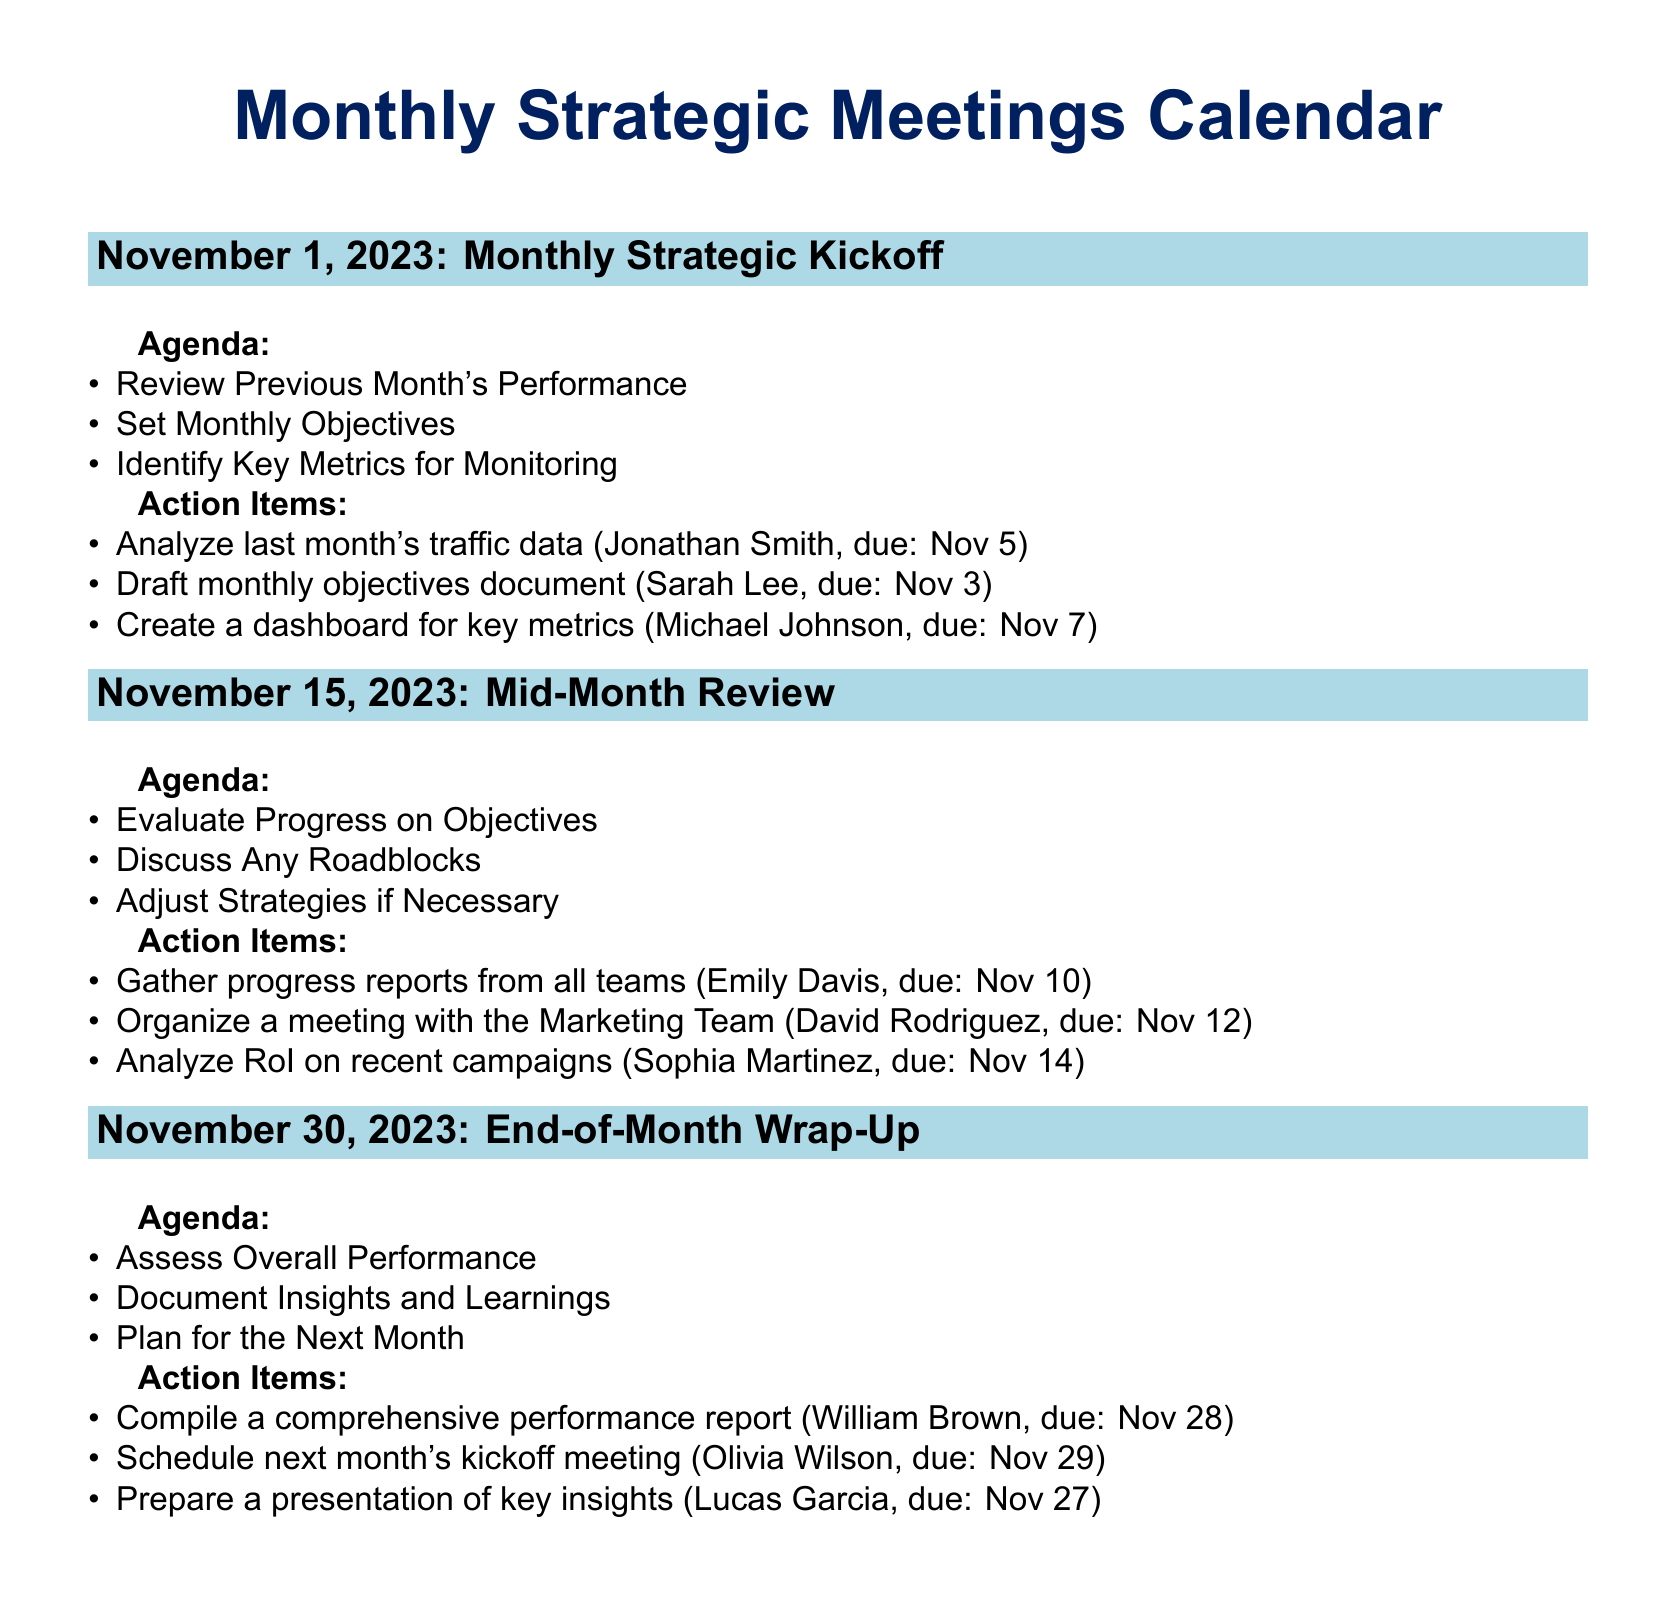What is the date of the Monthly Strategic Kickoff meeting? The date of the Monthly Strategic Kickoff meeting is listed in the document.
Answer: November 1, 2023 Who is responsible for drafting the monthly objectives document? The document specifies action items with assigned responsibilities.
Answer: Sarah Lee What is one of the items discussed during the Mid-Month Review? The document lists agenda items for each meeting.
Answer: Evaluate Progress on Objectives What action item is due on November 14? The document includes a list of action items with their due dates.
Answer: Analyze RoI on recent campaigns How many meetings are scheduled for November 2023? The document outlines three meetings for the month.
Answer: Three What is the purpose of the End-of-Month Wrap-Up meeting? The agenda describes the purpose of each meeting.
Answer: Assess Overall Performance Who is to compile the comprehensive performance report? The document lists specific individuals assigned to action items.
Answer: William Brown What is due on November 28? The document provides a date associated with a specific action item.
Answer: Compile a comprehensive performance report 